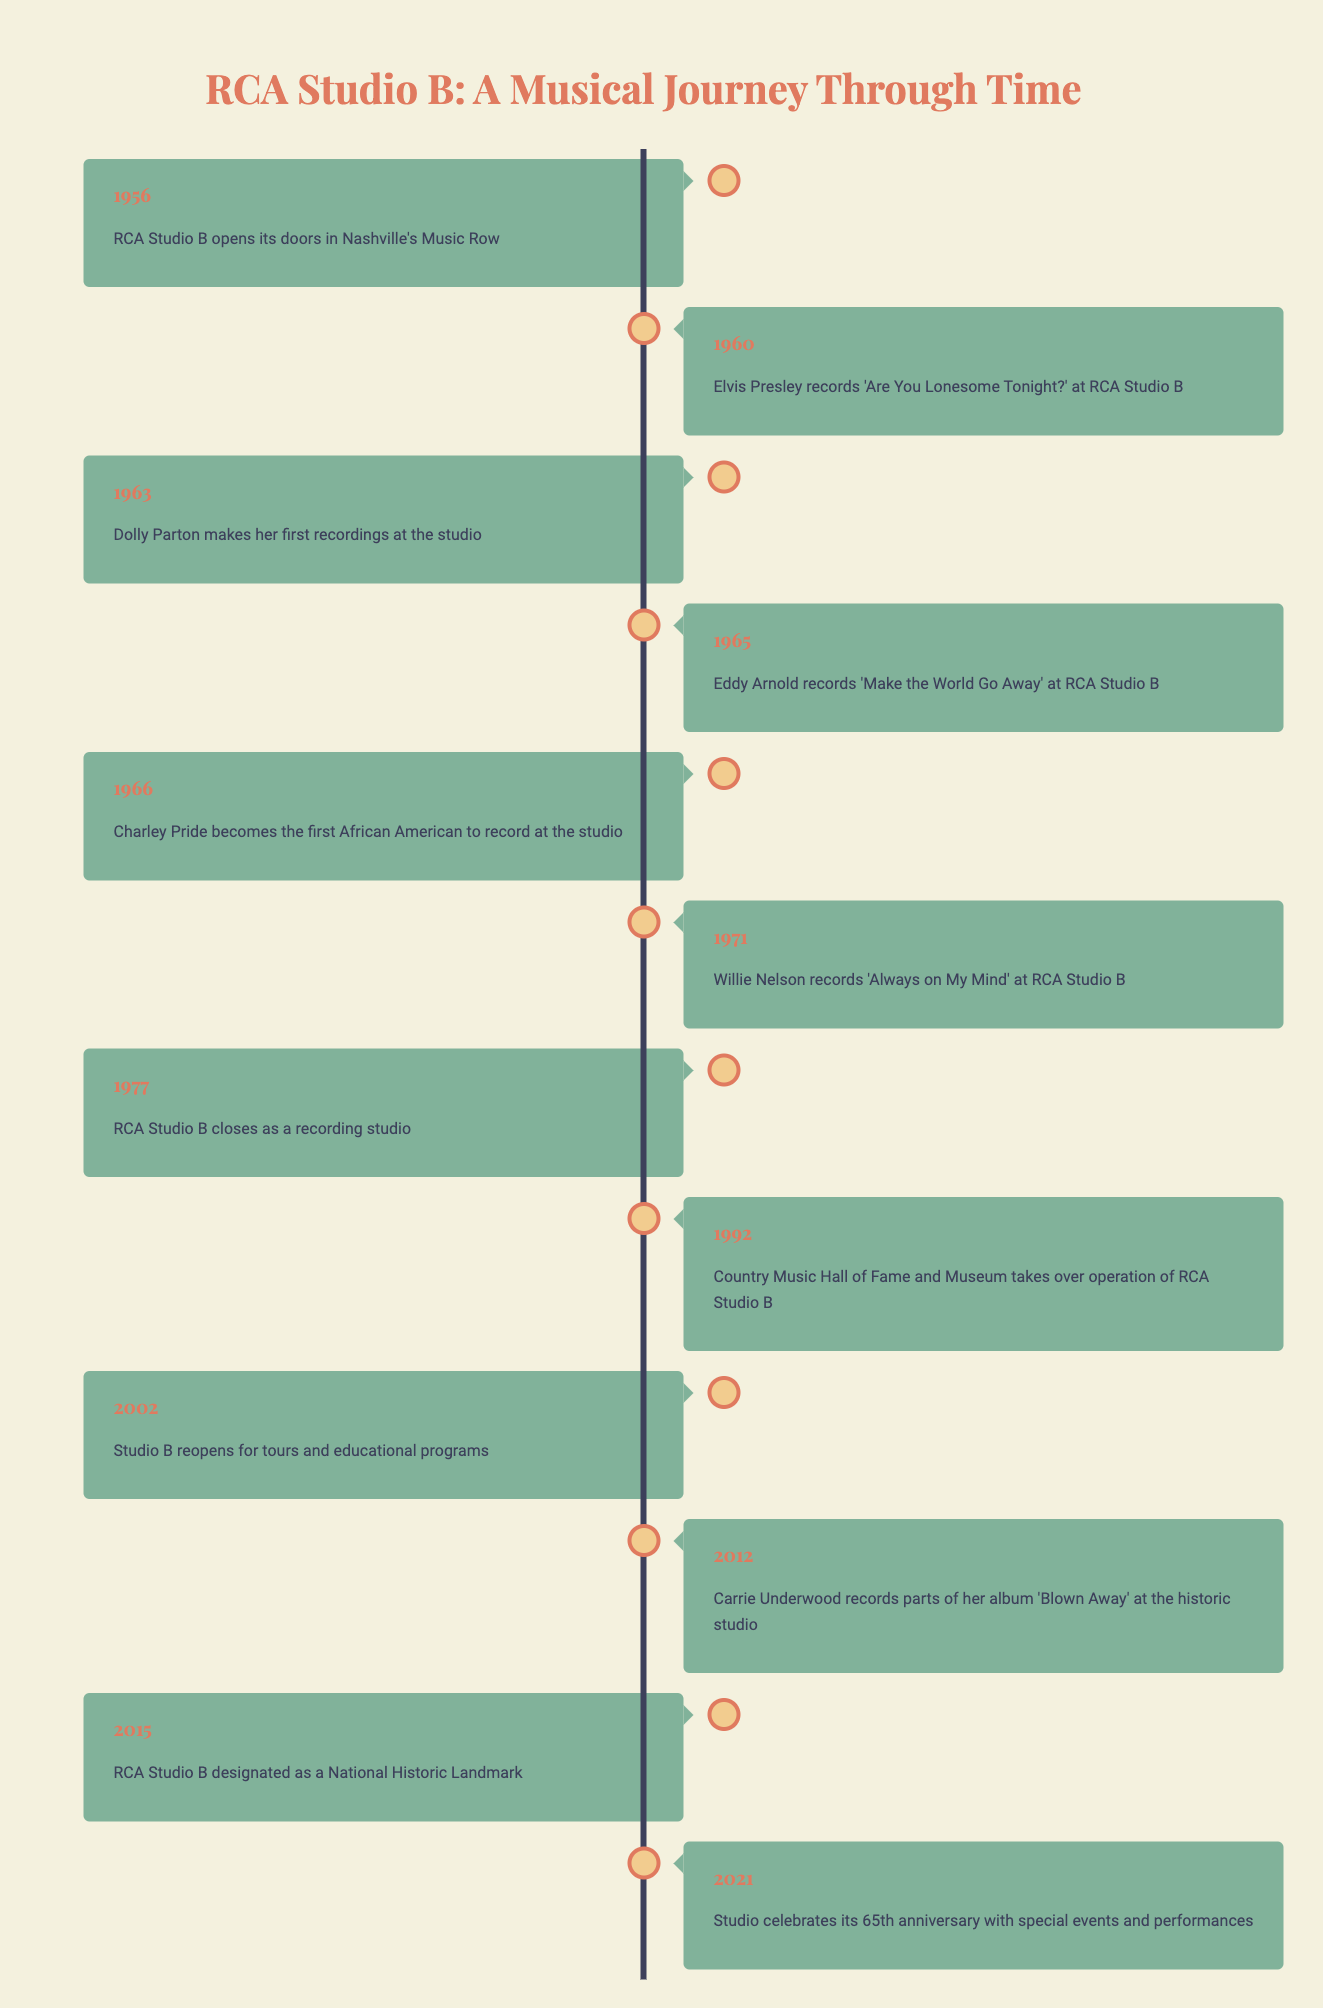What year did RCA Studio B open? The timeline indicates that RCA Studio B opened its doors in 1956. This information is found in the first entry of the timeline.
Answer: 1956 Which artist recorded 'Always on My Mind' at RCA Studio B? According to the timeline, Willie Nelson recorded 'Always on My Mind' at RCA Studio B in 1971. This is noted in the entry for that year.
Answer: Willie Nelson How many years was RCA Studio B operational as a recording studio before it closed? RCA Studio B opened in 1956 and closed in 1977. To find the duration of operation, we subtract the opening year from the closing year: 1977 - 1956 = 21. Thus, RCA Studio B was operational for 21 years.
Answer: 21 Was Dolly Parton the first artist to record at RCA Studio B? The timeline indicates that Dolly Parton made her first recordings at the studio in 1963, but it does not state that she was the first artist. The timeline shows that Elvis Presley recorded there in 1960, and Charley Pride also recorded there in 1966, making Dolly Parton not the first artist.
Answer: No In which year did RCA Studio B get designated as a National Historic Landmark? From the timeline, we can see that RCA Studio B was designated as a National Historic Landmark in 2015. This is clearly listed in the entry for that year.
Answer: 2015 Which artist was the first African American to record at RCA Studio B? The timeline specifies that Charley Pride became the first African American to record at RCA Studio B in 1966. This is stated in the entry for that year.
Answer: Charley Pride What significant event happened at RCA Studio B in 2021? The timeline highlights that in 2021, RCA Studio B celebrated its 65th anniversary with special events and performances. This information lets us know about the notable celebration that took place that year.
Answer: 65th anniversary celebration How many major events are recorded in the timeline? The timeline lists a total of 12 events from 1956 to 2021. By counting each entry in the timeline, we find that there are indeed 12 distinct events mentioned.
Answer: 12 